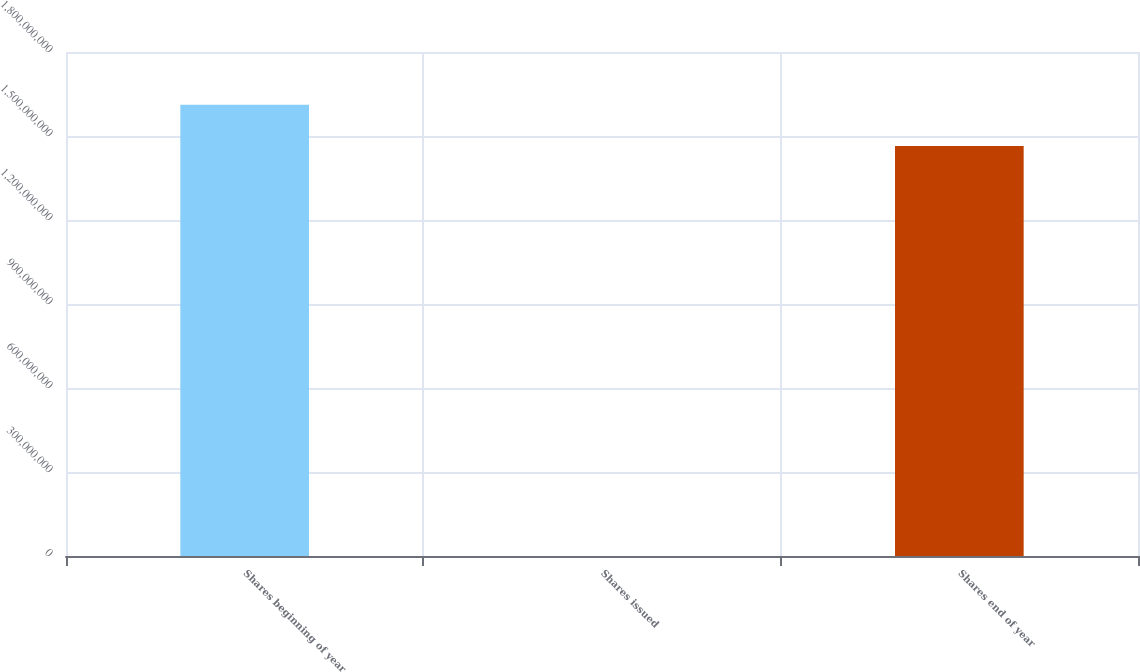Convert chart to OTSL. <chart><loc_0><loc_0><loc_500><loc_500><bar_chart><fcel>Shares beginning of year<fcel>Shares issued<fcel>Shares end of year<nl><fcel>1.61169e+09<fcel>58787<fcel>1.46406e+09<nl></chart> 